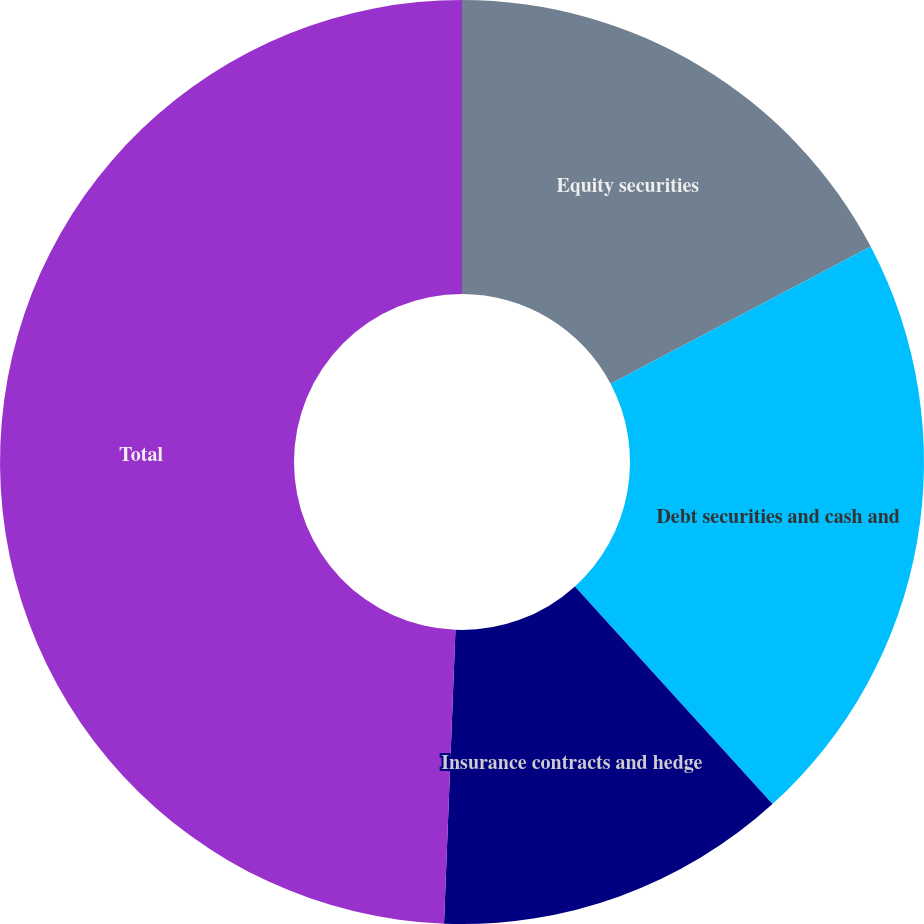Convert chart to OTSL. <chart><loc_0><loc_0><loc_500><loc_500><pie_chart><fcel>Equity securities<fcel>Debt securities and cash and<fcel>Insurance contracts and hedge<fcel>Total<nl><fcel>17.28%<fcel>20.99%<fcel>12.35%<fcel>49.38%<nl></chart> 